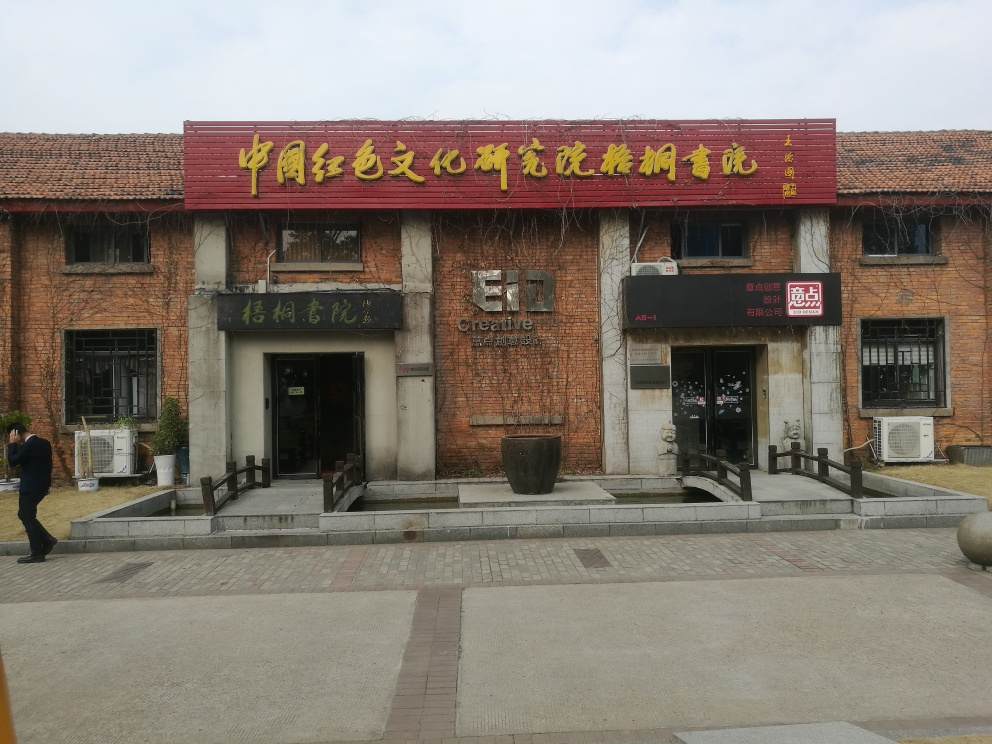What is the significance of the signs on the building? The signs on the building are in Chinese and indicate that the building serves as a place of interest, possibly housing businesses, artistic studios, or cultural exhibits. The presence of multiple businesses suggests it's a communal space, fostering a creative or entrepreneurial spirit. 